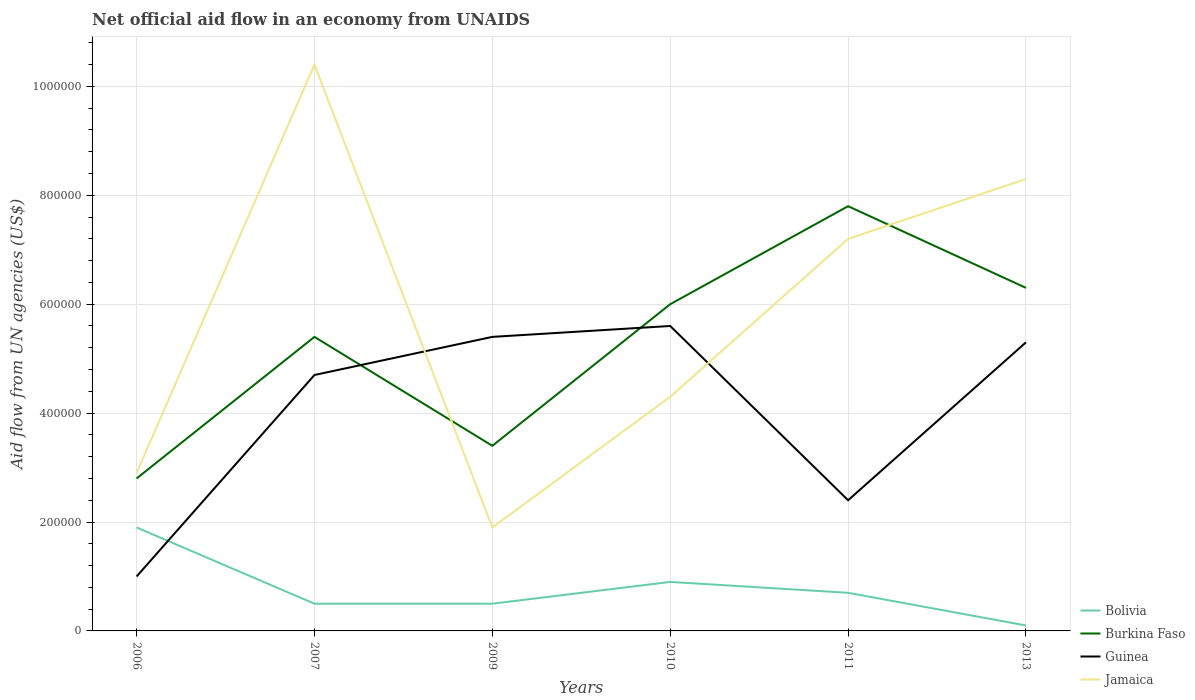How many different coloured lines are there?
Offer a terse response. 4. Across all years, what is the maximum net official aid flow in Burkina Faso?
Offer a terse response. 2.80e+05. What is the total net official aid flow in Jamaica in the graph?
Keep it short and to the point. -4.30e+05. What is the difference between the highest and the second highest net official aid flow in Burkina Faso?
Provide a succinct answer. 5.00e+05. What is the difference between the highest and the lowest net official aid flow in Jamaica?
Your answer should be compact. 3. Is the net official aid flow in Guinea strictly greater than the net official aid flow in Jamaica over the years?
Offer a terse response. No. How many lines are there?
Provide a short and direct response. 4. Are the values on the major ticks of Y-axis written in scientific E-notation?
Provide a short and direct response. No. Does the graph contain any zero values?
Your answer should be very brief. No. Does the graph contain grids?
Your response must be concise. Yes. Where does the legend appear in the graph?
Give a very brief answer. Bottom right. How many legend labels are there?
Offer a terse response. 4. What is the title of the graph?
Your answer should be very brief. Net official aid flow in an economy from UNAIDS. What is the label or title of the Y-axis?
Provide a short and direct response. Aid flow from UN agencies (US$). What is the Aid flow from UN agencies (US$) in Guinea in 2006?
Provide a succinct answer. 1.00e+05. What is the Aid flow from UN agencies (US$) of Jamaica in 2006?
Your answer should be very brief. 2.90e+05. What is the Aid flow from UN agencies (US$) in Bolivia in 2007?
Your answer should be compact. 5.00e+04. What is the Aid flow from UN agencies (US$) of Burkina Faso in 2007?
Keep it short and to the point. 5.40e+05. What is the Aid flow from UN agencies (US$) in Guinea in 2007?
Ensure brevity in your answer.  4.70e+05. What is the Aid flow from UN agencies (US$) in Jamaica in 2007?
Offer a very short reply. 1.04e+06. What is the Aid flow from UN agencies (US$) in Burkina Faso in 2009?
Provide a short and direct response. 3.40e+05. What is the Aid flow from UN agencies (US$) in Guinea in 2009?
Ensure brevity in your answer.  5.40e+05. What is the Aid flow from UN agencies (US$) of Bolivia in 2010?
Your answer should be very brief. 9.00e+04. What is the Aid flow from UN agencies (US$) in Burkina Faso in 2010?
Your response must be concise. 6.00e+05. What is the Aid flow from UN agencies (US$) of Guinea in 2010?
Offer a very short reply. 5.60e+05. What is the Aid flow from UN agencies (US$) of Jamaica in 2010?
Your answer should be compact. 4.30e+05. What is the Aid flow from UN agencies (US$) of Bolivia in 2011?
Ensure brevity in your answer.  7.00e+04. What is the Aid flow from UN agencies (US$) in Burkina Faso in 2011?
Keep it short and to the point. 7.80e+05. What is the Aid flow from UN agencies (US$) of Jamaica in 2011?
Offer a very short reply. 7.20e+05. What is the Aid flow from UN agencies (US$) of Bolivia in 2013?
Provide a succinct answer. 10000. What is the Aid flow from UN agencies (US$) of Burkina Faso in 2013?
Give a very brief answer. 6.30e+05. What is the Aid flow from UN agencies (US$) of Guinea in 2013?
Offer a terse response. 5.30e+05. What is the Aid flow from UN agencies (US$) of Jamaica in 2013?
Your answer should be compact. 8.30e+05. Across all years, what is the maximum Aid flow from UN agencies (US$) in Burkina Faso?
Your response must be concise. 7.80e+05. Across all years, what is the maximum Aid flow from UN agencies (US$) of Guinea?
Ensure brevity in your answer.  5.60e+05. Across all years, what is the maximum Aid flow from UN agencies (US$) in Jamaica?
Provide a short and direct response. 1.04e+06. Across all years, what is the minimum Aid flow from UN agencies (US$) of Jamaica?
Ensure brevity in your answer.  1.90e+05. What is the total Aid flow from UN agencies (US$) in Bolivia in the graph?
Make the answer very short. 4.60e+05. What is the total Aid flow from UN agencies (US$) of Burkina Faso in the graph?
Give a very brief answer. 3.17e+06. What is the total Aid flow from UN agencies (US$) of Guinea in the graph?
Your answer should be very brief. 2.44e+06. What is the total Aid flow from UN agencies (US$) of Jamaica in the graph?
Your answer should be very brief. 3.50e+06. What is the difference between the Aid flow from UN agencies (US$) in Bolivia in 2006 and that in 2007?
Make the answer very short. 1.40e+05. What is the difference between the Aid flow from UN agencies (US$) of Burkina Faso in 2006 and that in 2007?
Give a very brief answer. -2.60e+05. What is the difference between the Aid flow from UN agencies (US$) of Guinea in 2006 and that in 2007?
Ensure brevity in your answer.  -3.70e+05. What is the difference between the Aid flow from UN agencies (US$) of Jamaica in 2006 and that in 2007?
Your response must be concise. -7.50e+05. What is the difference between the Aid flow from UN agencies (US$) of Bolivia in 2006 and that in 2009?
Keep it short and to the point. 1.40e+05. What is the difference between the Aid flow from UN agencies (US$) in Guinea in 2006 and that in 2009?
Offer a very short reply. -4.40e+05. What is the difference between the Aid flow from UN agencies (US$) in Burkina Faso in 2006 and that in 2010?
Provide a succinct answer. -3.20e+05. What is the difference between the Aid flow from UN agencies (US$) of Guinea in 2006 and that in 2010?
Your answer should be compact. -4.60e+05. What is the difference between the Aid flow from UN agencies (US$) of Burkina Faso in 2006 and that in 2011?
Ensure brevity in your answer.  -5.00e+05. What is the difference between the Aid flow from UN agencies (US$) of Jamaica in 2006 and that in 2011?
Your answer should be very brief. -4.30e+05. What is the difference between the Aid flow from UN agencies (US$) in Bolivia in 2006 and that in 2013?
Your answer should be very brief. 1.80e+05. What is the difference between the Aid flow from UN agencies (US$) of Burkina Faso in 2006 and that in 2013?
Keep it short and to the point. -3.50e+05. What is the difference between the Aid flow from UN agencies (US$) in Guinea in 2006 and that in 2013?
Make the answer very short. -4.30e+05. What is the difference between the Aid flow from UN agencies (US$) of Jamaica in 2006 and that in 2013?
Provide a succinct answer. -5.40e+05. What is the difference between the Aid flow from UN agencies (US$) in Burkina Faso in 2007 and that in 2009?
Your answer should be very brief. 2.00e+05. What is the difference between the Aid flow from UN agencies (US$) in Guinea in 2007 and that in 2009?
Your answer should be compact. -7.00e+04. What is the difference between the Aid flow from UN agencies (US$) of Jamaica in 2007 and that in 2009?
Keep it short and to the point. 8.50e+05. What is the difference between the Aid flow from UN agencies (US$) of Bolivia in 2007 and that in 2010?
Keep it short and to the point. -4.00e+04. What is the difference between the Aid flow from UN agencies (US$) in Bolivia in 2007 and that in 2011?
Provide a short and direct response. -2.00e+04. What is the difference between the Aid flow from UN agencies (US$) of Burkina Faso in 2007 and that in 2011?
Make the answer very short. -2.40e+05. What is the difference between the Aid flow from UN agencies (US$) in Guinea in 2007 and that in 2011?
Keep it short and to the point. 2.30e+05. What is the difference between the Aid flow from UN agencies (US$) of Guinea in 2007 and that in 2013?
Give a very brief answer. -6.00e+04. What is the difference between the Aid flow from UN agencies (US$) in Guinea in 2009 and that in 2010?
Provide a short and direct response. -2.00e+04. What is the difference between the Aid flow from UN agencies (US$) of Bolivia in 2009 and that in 2011?
Your answer should be compact. -2.00e+04. What is the difference between the Aid flow from UN agencies (US$) in Burkina Faso in 2009 and that in 2011?
Provide a short and direct response. -4.40e+05. What is the difference between the Aid flow from UN agencies (US$) in Guinea in 2009 and that in 2011?
Your response must be concise. 3.00e+05. What is the difference between the Aid flow from UN agencies (US$) in Jamaica in 2009 and that in 2011?
Your response must be concise. -5.30e+05. What is the difference between the Aid flow from UN agencies (US$) of Bolivia in 2009 and that in 2013?
Offer a very short reply. 4.00e+04. What is the difference between the Aid flow from UN agencies (US$) in Jamaica in 2009 and that in 2013?
Make the answer very short. -6.40e+05. What is the difference between the Aid flow from UN agencies (US$) in Bolivia in 2010 and that in 2011?
Your answer should be very brief. 2.00e+04. What is the difference between the Aid flow from UN agencies (US$) of Burkina Faso in 2010 and that in 2011?
Provide a short and direct response. -1.80e+05. What is the difference between the Aid flow from UN agencies (US$) in Guinea in 2010 and that in 2013?
Offer a terse response. 3.00e+04. What is the difference between the Aid flow from UN agencies (US$) of Jamaica in 2010 and that in 2013?
Offer a terse response. -4.00e+05. What is the difference between the Aid flow from UN agencies (US$) in Burkina Faso in 2011 and that in 2013?
Offer a very short reply. 1.50e+05. What is the difference between the Aid flow from UN agencies (US$) in Guinea in 2011 and that in 2013?
Your response must be concise. -2.90e+05. What is the difference between the Aid flow from UN agencies (US$) in Bolivia in 2006 and the Aid flow from UN agencies (US$) in Burkina Faso in 2007?
Keep it short and to the point. -3.50e+05. What is the difference between the Aid flow from UN agencies (US$) in Bolivia in 2006 and the Aid flow from UN agencies (US$) in Guinea in 2007?
Your answer should be very brief. -2.80e+05. What is the difference between the Aid flow from UN agencies (US$) in Bolivia in 2006 and the Aid flow from UN agencies (US$) in Jamaica in 2007?
Your response must be concise. -8.50e+05. What is the difference between the Aid flow from UN agencies (US$) of Burkina Faso in 2006 and the Aid flow from UN agencies (US$) of Guinea in 2007?
Your response must be concise. -1.90e+05. What is the difference between the Aid flow from UN agencies (US$) in Burkina Faso in 2006 and the Aid flow from UN agencies (US$) in Jamaica in 2007?
Offer a terse response. -7.60e+05. What is the difference between the Aid flow from UN agencies (US$) in Guinea in 2006 and the Aid flow from UN agencies (US$) in Jamaica in 2007?
Make the answer very short. -9.40e+05. What is the difference between the Aid flow from UN agencies (US$) of Bolivia in 2006 and the Aid flow from UN agencies (US$) of Burkina Faso in 2009?
Provide a succinct answer. -1.50e+05. What is the difference between the Aid flow from UN agencies (US$) in Bolivia in 2006 and the Aid flow from UN agencies (US$) in Guinea in 2009?
Your response must be concise. -3.50e+05. What is the difference between the Aid flow from UN agencies (US$) in Bolivia in 2006 and the Aid flow from UN agencies (US$) in Jamaica in 2009?
Give a very brief answer. 0. What is the difference between the Aid flow from UN agencies (US$) of Burkina Faso in 2006 and the Aid flow from UN agencies (US$) of Jamaica in 2009?
Offer a very short reply. 9.00e+04. What is the difference between the Aid flow from UN agencies (US$) in Guinea in 2006 and the Aid flow from UN agencies (US$) in Jamaica in 2009?
Your response must be concise. -9.00e+04. What is the difference between the Aid flow from UN agencies (US$) in Bolivia in 2006 and the Aid flow from UN agencies (US$) in Burkina Faso in 2010?
Your response must be concise. -4.10e+05. What is the difference between the Aid flow from UN agencies (US$) of Bolivia in 2006 and the Aid flow from UN agencies (US$) of Guinea in 2010?
Keep it short and to the point. -3.70e+05. What is the difference between the Aid flow from UN agencies (US$) of Burkina Faso in 2006 and the Aid flow from UN agencies (US$) of Guinea in 2010?
Give a very brief answer. -2.80e+05. What is the difference between the Aid flow from UN agencies (US$) in Guinea in 2006 and the Aid flow from UN agencies (US$) in Jamaica in 2010?
Keep it short and to the point. -3.30e+05. What is the difference between the Aid flow from UN agencies (US$) in Bolivia in 2006 and the Aid flow from UN agencies (US$) in Burkina Faso in 2011?
Your answer should be compact. -5.90e+05. What is the difference between the Aid flow from UN agencies (US$) in Bolivia in 2006 and the Aid flow from UN agencies (US$) in Guinea in 2011?
Keep it short and to the point. -5.00e+04. What is the difference between the Aid flow from UN agencies (US$) of Bolivia in 2006 and the Aid flow from UN agencies (US$) of Jamaica in 2011?
Keep it short and to the point. -5.30e+05. What is the difference between the Aid flow from UN agencies (US$) of Burkina Faso in 2006 and the Aid flow from UN agencies (US$) of Guinea in 2011?
Ensure brevity in your answer.  4.00e+04. What is the difference between the Aid flow from UN agencies (US$) in Burkina Faso in 2006 and the Aid flow from UN agencies (US$) in Jamaica in 2011?
Offer a terse response. -4.40e+05. What is the difference between the Aid flow from UN agencies (US$) in Guinea in 2006 and the Aid flow from UN agencies (US$) in Jamaica in 2011?
Your response must be concise. -6.20e+05. What is the difference between the Aid flow from UN agencies (US$) in Bolivia in 2006 and the Aid flow from UN agencies (US$) in Burkina Faso in 2013?
Keep it short and to the point. -4.40e+05. What is the difference between the Aid flow from UN agencies (US$) in Bolivia in 2006 and the Aid flow from UN agencies (US$) in Jamaica in 2013?
Ensure brevity in your answer.  -6.40e+05. What is the difference between the Aid flow from UN agencies (US$) of Burkina Faso in 2006 and the Aid flow from UN agencies (US$) of Jamaica in 2013?
Offer a very short reply. -5.50e+05. What is the difference between the Aid flow from UN agencies (US$) in Guinea in 2006 and the Aid flow from UN agencies (US$) in Jamaica in 2013?
Your answer should be very brief. -7.30e+05. What is the difference between the Aid flow from UN agencies (US$) of Bolivia in 2007 and the Aid flow from UN agencies (US$) of Burkina Faso in 2009?
Your answer should be compact. -2.90e+05. What is the difference between the Aid flow from UN agencies (US$) in Bolivia in 2007 and the Aid flow from UN agencies (US$) in Guinea in 2009?
Your response must be concise. -4.90e+05. What is the difference between the Aid flow from UN agencies (US$) of Burkina Faso in 2007 and the Aid flow from UN agencies (US$) of Jamaica in 2009?
Keep it short and to the point. 3.50e+05. What is the difference between the Aid flow from UN agencies (US$) in Guinea in 2007 and the Aid flow from UN agencies (US$) in Jamaica in 2009?
Your answer should be very brief. 2.80e+05. What is the difference between the Aid flow from UN agencies (US$) of Bolivia in 2007 and the Aid flow from UN agencies (US$) of Burkina Faso in 2010?
Offer a very short reply. -5.50e+05. What is the difference between the Aid flow from UN agencies (US$) in Bolivia in 2007 and the Aid flow from UN agencies (US$) in Guinea in 2010?
Your answer should be compact. -5.10e+05. What is the difference between the Aid flow from UN agencies (US$) of Bolivia in 2007 and the Aid flow from UN agencies (US$) of Jamaica in 2010?
Provide a succinct answer. -3.80e+05. What is the difference between the Aid flow from UN agencies (US$) of Burkina Faso in 2007 and the Aid flow from UN agencies (US$) of Guinea in 2010?
Give a very brief answer. -2.00e+04. What is the difference between the Aid flow from UN agencies (US$) in Burkina Faso in 2007 and the Aid flow from UN agencies (US$) in Jamaica in 2010?
Your response must be concise. 1.10e+05. What is the difference between the Aid flow from UN agencies (US$) in Guinea in 2007 and the Aid flow from UN agencies (US$) in Jamaica in 2010?
Ensure brevity in your answer.  4.00e+04. What is the difference between the Aid flow from UN agencies (US$) of Bolivia in 2007 and the Aid flow from UN agencies (US$) of Burkina Faso in 2011?
Provide a succinct answer. -7.30e+05. What is the difference between the Aid flow from UN agencies (US$) of Bolivia in 2007 and the Aid flow from UN agencies (US$) of Jamaica in 2011?
Provide a short and direct response. -6.70e+05. What is the difference between the Aid flow from UN agencies (US$) of Burkina Faso in 2007 and the Aid flow from UN agencies (US$) of Guinea in 2011?
Keep it short and to the point. 3.00e+05. What is the difference between the Aid flow from UN agencies (US$) of Burkina Faso in 2007 and the Aid flow from UN agencies (US$) of Jamaica in 2011?
Keep it short and to the point. -1.80e+05. What is the difference between the Aid flow from UN agencies (US$) of Bolivia in 2007 and the Aid flow from UN agencies (US$) of Burkina Faso in 2013?
Keep it short and to the point. -5.80e+05. What is the difference between the Aid flow from UN agencies (US$) of Bolivia in 2007 and the Aid flow from UN agencies (US$) of Guinea in 2013?
Give a very brief answer. -4.80e+05. What is the difference between the Aid flow from UN agencies (US$) of Bolivia in 2007 and the Aid flow from UN agencies (US$) of Jamaica in 2013?
Your answer should be compact. -7.80e+05. What is the difference between the Aid flow from UN agencies (US$) of Burkina Faso in 2007 and the Aid flow from UN agencies (US$) of Guinea in 2013?
Keep it short and to the point. 10000. What is the difference between the Aid flow from UN agencies (US$) of Burkina Faso in 2007 and the Aid flow from UN agencies (US$) of Jamaica in 2013?
Ensure brevity in your answer.  -2.90e+05. What is the difference between the Aid flow from UN agencies (US$) of Guinea in 2007 and the Aid flow from UN agencies (US$) of Jamaica in 2013?
Make the answer very short. -3.60e+05. What is the difference between the Aid flow from UN agencies (US$) of Bolivia in 2009 and the Aid flow from UN agencies (US$) of Burkina Faso in 2010?
Your answer should be very brief. -5.50e+05. What is the difference between the Aid flow from UN agencies (US$) in Bolivia in 2009 and the Aid flow from UN agencies (US$) in Guinea in 2010?
Your answer should be very brief. -5.10e+05. What is the difference between the Aid flow from UN agencies (US$) of Bolivia in 2009 and the Aid flow from UN agencies (US$) of Jamaica in 2010?
Offer a very short reply. -3.80e+05. What is the difference between the Aid flow from UN agencies (US$) of Burkina Faso in 2009 and the Aid flow from UN agencies (US$) of Jamaica in 2010?
Ensure brevity in your answer.  -9.00e+04. What is the difference between the Aid flow from UN agencies (US$) in Guinea in 2009 and the Aid flow from UN agencies (US$) in Jamaica in 2010?
Your answer should be very brief. 1.10e+05. What is the difference between the Aid flow from UN agencies (US$) in Bolivia in 2009 and the Aid flow from UN agencies (US$) in Burkina Faso in 2011?
Offer a terse response. -7.30e+05. What is the difference between the Aid flow from UN agencies (US$) in Bolivia in 2009 and the Aid flow from UN agencies (US$) in Jamaica in 2011?
Keep it short and to the point. -6.70e+05. What is the difference between the Aid flow from UN agencies (US$) in Burkina Faso in 2009 and the Aid flow from UN agencies (US$) in Guinea in 2011?
Provide a succinct answer. 1.00e+05. What is the difference between the Aid flow from UN agencies (US$) of Burkina Faso in 2009 and the Aid flow from UN agencies (US$) of Jamaica in 2011?
Your answer should be very brief. -3.80e+05. What is the difference between the Aid flow from UN agencies (US$) of Guinea in 2009 and the Aid flow from UN agencies (US$) of Jamaica in 2011?
Your answer should be very brief. -1.80e+05. What is the difference between the Aid flow from UN agencies (US$) in Bolivia in 2009 and the Aid flow from UN agencies (US$) in Burkina Faso in 2013?
Ensure brevity in your answer.  -5.80e+05. What is the difference between the Aid flow from UN agencies (US$) in Bolivia in 2009 and the Aid flow from UN agencies (US$) in Guinea in 2013?
Provide a succinct answer. -4.80e+05. What is the difference between the Aid flow from UN agencies (US$) in Bolivia in 2009 and the Aid flow from UN agencies (US$) in Jamaica in 2013?
Keep it short and to the point. -7.80e+05. What is the difference between the Aid flow from UN agencies (US$) in Burkina Faso in 2009 and the Aid flow from UN agencies (US$) in Guinea in 2013?
Ensure brevity in your answer.  -1.90e+05. What is the difference between the Aid flow from UN agencies (US$) in Burkina Faso in 2009 and the Aid flow from UN agencies (US$) in Jamaica in 2013?
Your answer should be very brief. -4.90e+05. What is the difference between the Aid flow from UN agencies (US$) of Guinea in 2009 and the Aid flow from UN agencies (US$) of Jamaica in 2013?
Keep it short and to the point. -2.90e+05. What is the difference between the Aid flow from UN agencies (US$) in Bolivia in 2010 and the Aid flow from UN agencies (US$) in Burkina Faso in 2011?
Keep it short and to the point. -6.90e+05. What is the difference between the Aid flow from UN agencies (US$) in Bolivia in 2010 and the Aid flow from UN agencies (US$) in Jamaica in 2011?
Offer a terse response. -6.30e+05. What is the difference between the Aid flow from UN agencies (US$) in Burkina Faso in 2010 and the Aid flow from UN agencies (US$) in Guinea in 2011?
Offer a very short reply. 3.60e+05. What is the difference between the Aid flow from UN agencies (US$) of Bolivia in 2010 and the Aid flow from UN agencies (US$) of Burkina Faso in 2013?
Provide a succinct answer. -5.40e+05. What is the difference between the Aid flow from UN agencies (US$) in Bolivia in 2010 and the Aid flow from UN agencies (US$) in Guinea in 2013?
Ensure brevity in your answer.  -4.40e+05. What is the difference between the Aid flow from UN agencies (US$) in Bolivia in 2010 and the Aid flow from UN agencies (US$) in Jamaica in 2013?
Ensure brevity in your answer.  -7.40e+05. What is the difference between the Aid flow from UN agencies (US$) of Bolivia in 2011 and the Aid flow from UN agencies (US$) of Burkina Faso in 2013?
Give a very brief answer. -5.60e+05. What is the difference between the Aid flow from UN agencies (US$) in Bolivia in 2011 and the Aid flow from UN agencies (US$) in Guinea in 2013?
Your answer should be very brief. -4.60e+05. What is the difference between the Aid flow from UN agencies (US$) in Bolivia in 2011 and the Aid flow from UN agencies (US$) in Jamaica in 2013?
Provide a succinct answer. -7.60e+05. What is the difference between the Aid flow from UN agencies (US$) of Burkina Faso in 2011 and the Aid flow from UN agencies (US$) of Jamaica in 2013?
Give a very brief answer. -5.00e+04. What is the difference between the Aid flow from UN agencies (US$) of Guinea in 2011 and the Aid flow from UN agencies (US$) of Jamaica in 2013?
Offer a terse response. -5.90e+05. What is the average Aid flow from UN agencies (US$) of Bolivia per year?
Your answer should be very brief. 7.67e+04. What is the average Aid flow from UN agencies (US$) in Burkina Faso per year?
Provide a short and direct response. 5.28e+05. What is the average Aid flow from UN agencies (US$) in Guinea per year?
Your answer should be compact. 4.07e+05. What is the average Aid flow from UN agencies (US$) in Jamaica per year?
Offer a very short reply. 5.83e+05. In the year 2006, what is the difference between the Aid flow from UN agencies (US$) of Bolivia and Aid flow from UN agencies (US$) of Burkina Faso?
Offer a terse response. -9.00e+04. In the year 2006, what is the difference between the Aid flow from UN agencies (US$) in Bolivia and Aid flow from UN agencies (US$) in Guinea?
Ensure brevity in your answer.  9.00e+04. In the year 2007, what is the difference between the Aid flow from UN agencies (US$) in Bolivia and Aid flow from UN agencies (US$) in Burkina Faso?
Ensure brevity in your answer.  -4.90e+05. In the year 2007, what is the difference between the Aid flow from UN agencies (US$) of Bolivia and Aid flow from UN agencies (US$) of Guinea?
Provide a short and direct response. -4.20e+05. In the year 2007, what is the difference between the Aid flow from UN agencies (US$) of Bolivia and Aid flow from UN agencies (US$) of Jamaica?
Your answer should be compact. -9.90e+05. In the year 2007, what is the difference between the Aid flow from UN agencies (US$) in Burkina Faso and Aid flow from UN agencies (US$) in Guinea?
Give a very brief answer. 7.00e+04. In the year 2007, what is the difference between the Aid flow from UN agencies (US$) in Burkina Faso and Aid flow from UN agencies (US$) in Jamaica?
Make the answer very short. -5.00e+05. In the year 2007, what is the difference between the Aid flow from UN agencies (US$) in Guinea and Aid flow from UN agencies (US$) in Jamaica?
Make the answer very short. -5.70e+05. In the year 2009, what is the difference between the Aid flow from UN agencies (US$) of Bolivia and Aid flow from UN agencies (US$) of Guinea?
Offer a terse response. -4.90e+05. In the year 2009, what is the difference between the Aid flow from UN agencies (US$) of Bolivia and Aid flow from UN agencies (US$) of Jamaica?
Offer a terse response. -1.40e+05. In the year 2009, what is the difference between the Aid flow from UN agencies (US$) of Burkina Faso and Aid flow from UN agencies (US$) of Jamaica?
Ensure brevity in your answer.  1.50e+05. In the year 2009, what is the difference between the Aid flow from UN agencies (US$) of Guinea and Aid flow from UN agencies (US$) of Jamaica?
Give a very brief answer. 3.50e+05. In the year 2010, what is the difference between the Aid flow from UN agencies (US$) in Bolivia and Aid flow from UN agencies (US$) in Burkina Faso?
Offer a terse response. -5.10e+05. In the year 2010, what is the difference between the Aid flow from UN agencies (US$) of Bolivia and Aid flow from UN agencies (US$) of Guinea?
Your response must be concise. -4.70e+05. In the year 2010, what is the difference between the Aid flow from UN agencies (US$) of Burkina Faso and Aid flow from UN agencies (US$) of Guinea?
Provide a succinct answer. 4.00e+04. In the year 2011, what is the difference between the Aid flow from UN agencies (US$) of Bolivia and Aid flow from UN agencies (US$) of Burkina Faso?
Provide a short and direct response. -7.10e+05. In the year 2011, what is the difference between the Aid flow from UN agencies (US$) in Bolivia and Aid flow from UN agencies (US$) in Guinea?
Your answer should be very brief. -1.70e+05. In the year 2011, what is the difference between the Aid flow from UN agencies (US$) in Bolivia and Aid flow from UN agencies (US$) in Jamaica?
Ensure brevity in your answer.  -6.50e+05. In the year 2011, what is the difference between the Aid flow from UN agencies (US$) in Burkina Faso and Aid flow from UN agencies (US$) in Guinea?
Your response must be concise. 5.40e+05. In the year 2011, what is the difference between the Aid flow from UN agencies (US$) of Guinea and Aid flow from UN agencies (US$) of Jamaica?
Offer a terse response. -4.80e+05. In the year 2013, what is the difference between the Aid flow from UN agencies (US$) of Bolivia and Aid flow from UN agencies (US$) of Burkina Faso?
Keep it short and to the point. -6.20e+05. In the year 2013, what is the difference between the Aid flow from UN agencies (US$) of Bolivia and Aid flow from UN agencies (US$) of Guinea?
Keep it short and to the point. -5.20e+05. In the year 2013, what is the difference between the Aid flow from UN agencies (US$) of Bolivia and Aid flow from UN agencies (US$) of Jamaica?
Give a very brief answer. -8.20e+05. In the year 2013, what is the difference between the Aid flow from UN agencies (US$) in Burkina Faso and Aid flow from UN agencies (US$) in Guinea?
Ensure brevity in your answer.  1.00e+05. In the year 2013, what is the difference between the Aid flow from UN agencies (US$) of Guinea and Aid flow from UN agencies (US$) of Jamaica?
Your answer should be very brief. -3.00e+05. What is the ratio of the Aid flow from UN agencies (US$) of Bolivia in 2006 to that in 2007?
Offer a terse response. 3.8. What is the ratio of the Aid flow from UN agencies (US$) in Burkina Faso in 2006 to that in 2007?
Offer a very short reply. 0.52. What is the ratio of the Aid flow from UN agencies (US$) in Guinea in 2006 to that in 2007?
Give a very brief answer. 0.21. What is the ratio of the Aid flow from UN agencies (US$) of Jamaica in 2006 to that in 2007?
Provide a short and direct response. 0.28. What is the ratio of the Aid flow from UN agencies (US$) of Burkina Faso in 2006 to that in 2009?
Provide a short and direct response. 0.82. What is the ratio of the Aid flow from UN agencies (US$) in Guinea in 2006 to that in 2009?
Make the answer very short. 0.19. What is the ratio of the Aid flow from UN agencies (US$) in Jamaica in 2006 to that in 2009?
Keep it short and to the point. 1.53. What is the ratio of the Aid flow from UN agencies (US$) of Bolivia in 2006 to that in 2010?
Ensure brevity in your answer.  2.11. What is the ratio of the Aid flow from UN agencies (US$) in Burkina Faso in 2006 to that in 2010?
Provide a succinct answer. 0.47. What is the ratio of the Aid flow from UN agencies (US$) of Guinea in 2006 to that in 2010?
Provide a short and direct response. 0.18. What is the ratio of the Aid flow from UN agencies (US$) of Jamaica in 2006 to that in 2010?
Offer a very short reply. 0.67. What is the ratio of the Aid flow from UN agencies (US$) of Bolivia in 2006 to that in 2011?
Give a very brief answer. 2.71. What is the ratio of the Aid flow from UN agencies (US$) in Burkina Faso in 2006 to that in 2011?
Your answer should be compact. 0.36. What is the ratio of the Aid flow from UN agencies (US$) of Guinea in 2006 to that in 2011?
Ensure brevity in your answer.  0.42. What is the ratio of the Aid flow from UN agencies (US$) in Jamaica in 2006 to that in 2011?
Make the answer very short. 0.4. What is the ratio of the Aid flow from UN agencies (US$) in Bolivia in 2006 to that in 2013?
Offer a very short reply. 19. What is the ratio of the Aid flow from UN agencies (US$) in Burkina Faso in 2006 to that in 2013?
Provide a short and direct response. 0.44. What is the ratio of the Aid flow from UN agencies (US$) in Guinea in 2006 to that in 2013?
Offer a terse response. 0.19. What is the ratio of the Aid flow from UN agencies (US$) of Jamaica in 2006 to that in 2013?
Give a very brief answer. 0.35. What is the ratio of the Aid flow from UN agencies (US$) in Bolivia in 2007 to that in 2009?
Ensure brevity in your answer.  1. What is the ratio of the Aid flow from UN agencies (US$) in Burkina Faso in 2007 to that in 2009?
Provide a short and direct response. 1.59. What is the ratio of the Aid flow from UN agencies (US$) of Guinea in 2007 to that in 2009?
Offer a very short reply. 0.87. What is the ratio of the Aid flow from UN agencies (US$) in Jamaica in 2007 to that in 2009?
Your response must be concise. 5.47. What is the ratio of the Aid flow from UN agencies (US$) of Bolivia in 2007 to that in 2010?
Your response must be concise. 0.56. What is the ratio of the Aid flow from UN agencies (US$) in Burkina Faso in 2007 to that in 2010?
Give a very brief answer. 0.9. What is the ratio of the Aid flow from UN agencies (US$) in Guinea in 2007 to that in 2010?
Your answer should be compact. 0.84. What is the ratio of the Aid flow from UN agencies (US$) of Jamaica in 2007 to that in 2010?
Your answer should be compact. 2.42. What is the ratio of the Aid flow from UN agencies (US$) of Bolivia in 2007 to that in 2011?
Your answer should be compact. 0.71. What is the ratio of the Aid flow from UN agencies (US$) in Burkina Faso in 2007 to that in 2011?
Ensure brevity in your answer.  0.69. What is the ratio of the Aid flow from UN agencies (US$) of Guinea in 2007 to that in 2011?
Keep it short and to the point. 1.96. What is the ratio of the Aid flow from UN agencies (US$) of Jamaica in 2007 to that in 2011?
Your answer should be very brief. 1.44. What is the ratio of the Aid flow from UN agencies (US$) of Burkina Faso in 2007 to that in 2013?
Your answer should be very brief. 0.86. What is the ratio of the Aid flow from UN agencies (US$) of Guinea in 2007 to that in 2013?
Provide a succinct answer. 0.89. What is the ratio of the Aid flow from UN agencies (US$) in Jamaica in 2007 to that in 2013?
Keep it short and to the point. 1.25. What is the ratio of the Aid flow from UN agencies (US$) in Bolivia in 2009 to that in 2010?
Keep it short and to the point. 0.56. What is the ratio of the Aid flow from UN agencies (US$) of Burkina Faso in 2009 to that in 2010?
Your response must be concise. 0.57. What is the ratio of the Aid flow from UN agencies (US$) of Jamaica in 2009 to that in 2010?
Offer a terse response. 0.44. What is the ratio of the Aid flow from UN agencies (US$) of Burkina Faso in 2009 to that in 2011?
Offer a terse response. 0.44. What is the ratio of the Aid flow from UN agencies (US$) in Guinea in 2009 to that in 2011?
Provide a short and direct response. 2.25. What is the ratio of the Aid flow from UN agencies (US$) in Jamaica in 2009 to that in 2011?
Offer a very short reply. 0.26. What is the ratio of the Aid flow from UN agencies (US$) of Bolivia in 2009 to that in 2013?
Offer a terse response. 5. What is the ratio of the Aid flow from UN agencies (US$) in Burkina Faso in 2009 to that in 2013?
Your answer should be very brief. 0.54. What is the ratio of the Aid flow from UN agencies (US$) in Guinea in 2009 to that in 2013?
Offer a very short reply. 1.02. What is the ratio of the Aid flow from UN agencies (US$) in Jamaica in 2009 to that in 2013?
Ensure brevity in your answer.  0.23. What is the ratio of the Aid flow from UN agencies (US$) in Burkina Faso in 2010 to that in 2011?
Ensure brevity in your answer.  0.77. What is the ratio of the Aid flow from UN agencies (US$) in Guinea in 2010 to that in 2011?
Your answer should be compact. 2.33. What is the ratio of the Aid flow from UN agencies (US$) in Jamaica in 2010 to that in 2011?
Keep it short and to the point. 0.6. What is the ratio of the Aid flow from UN agencies (US$) of Bolivia in 2010 to that in 2013?
Make the answer very short. 9. What is the ratio of the Aid flow from UN agencies (US$) of Guinea in 2010 to that in 2013?
Provide a short and direct response. 1.06. What is the ratio of the Aid flow from UN agencies (US$) in Jamaica in 2010 to that in 2013?
Provide a short and direct response. 0.52. What is the ratio of the Aid flow from UN agencies (US$) in Burkina Faso in 2011 to that in 2013?
Provide a short and direct response. 1.24. What is the ratio of the Aid flow from UN agencies (US$) in Guinea in 2011 to that in 2013?
Offer a very short reply. 0.45. What is the ratio of the Aid flow from UN agencies (US$) of Jamaica in 2011 to that in 2013?
Your answer should be compact. 0.87. What is the difference between the highest and the second highest Aid flow from UN agencies (US$) of Bolivia?
Keep it short and to the point. 1.00e+05. What is the difference between the highest and the second highest Aid flow from UN agencies (US$) of Burkina Faso?
Ensure brevity in your answer.  1.50e+05. What is the difference between the highest and the second highest Aid flow from UN agencies (US$) in Guinea?
Give a very brief answer. 2.00e+04. What is the difference between the highest and the lowest Aid flow from UN agencies (US$) of Jamaica?
Your response must be concise. 8.50e+05. 